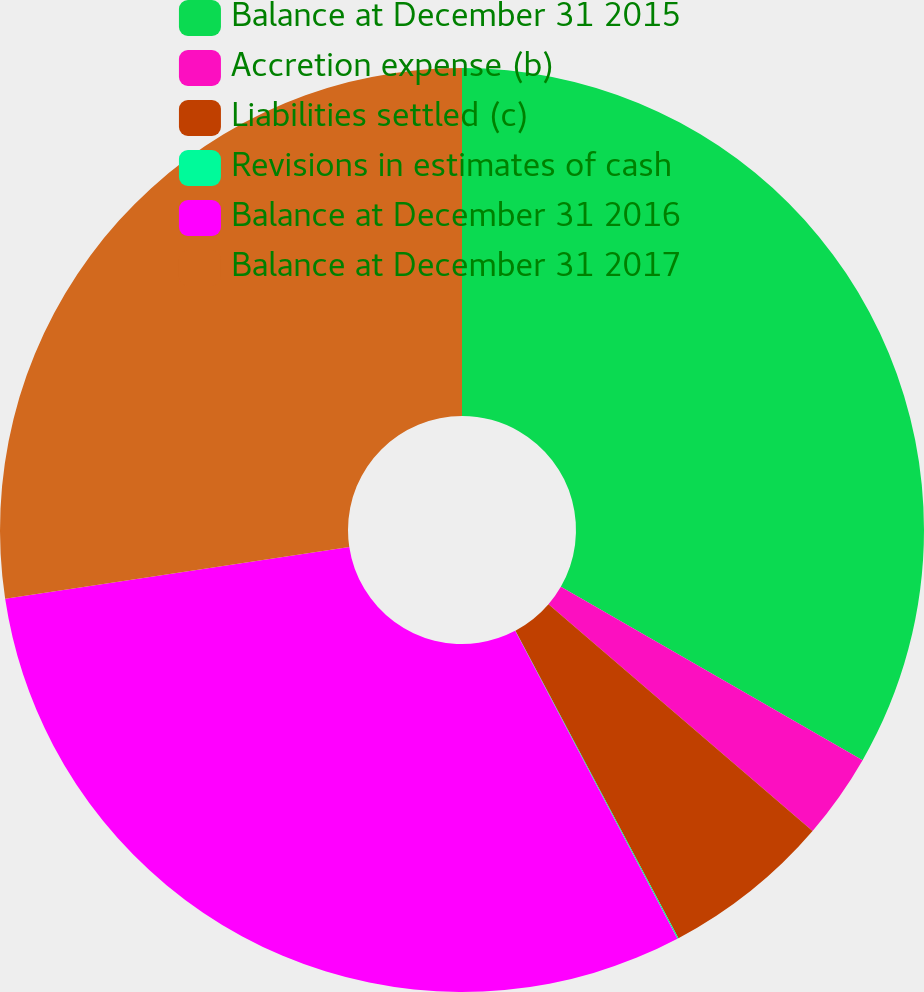<chart> <loc_0><loc_0><loc_500><loc_500><pie_chart><fcel>Balance at December 31 2015<fcel>Accretion expense (b)<fcel>Liabilities settled (c)<fcel>Revisions in estimates of cash<fcel>Balance at December 31 2016<fcel>Balance at December 31 2017<nl><fcel>33.3%<fcel>2.99%<fcel>5.95%<fcel>0.04%<fcel>30.34%<fcel>27.38%<nl></chart> 